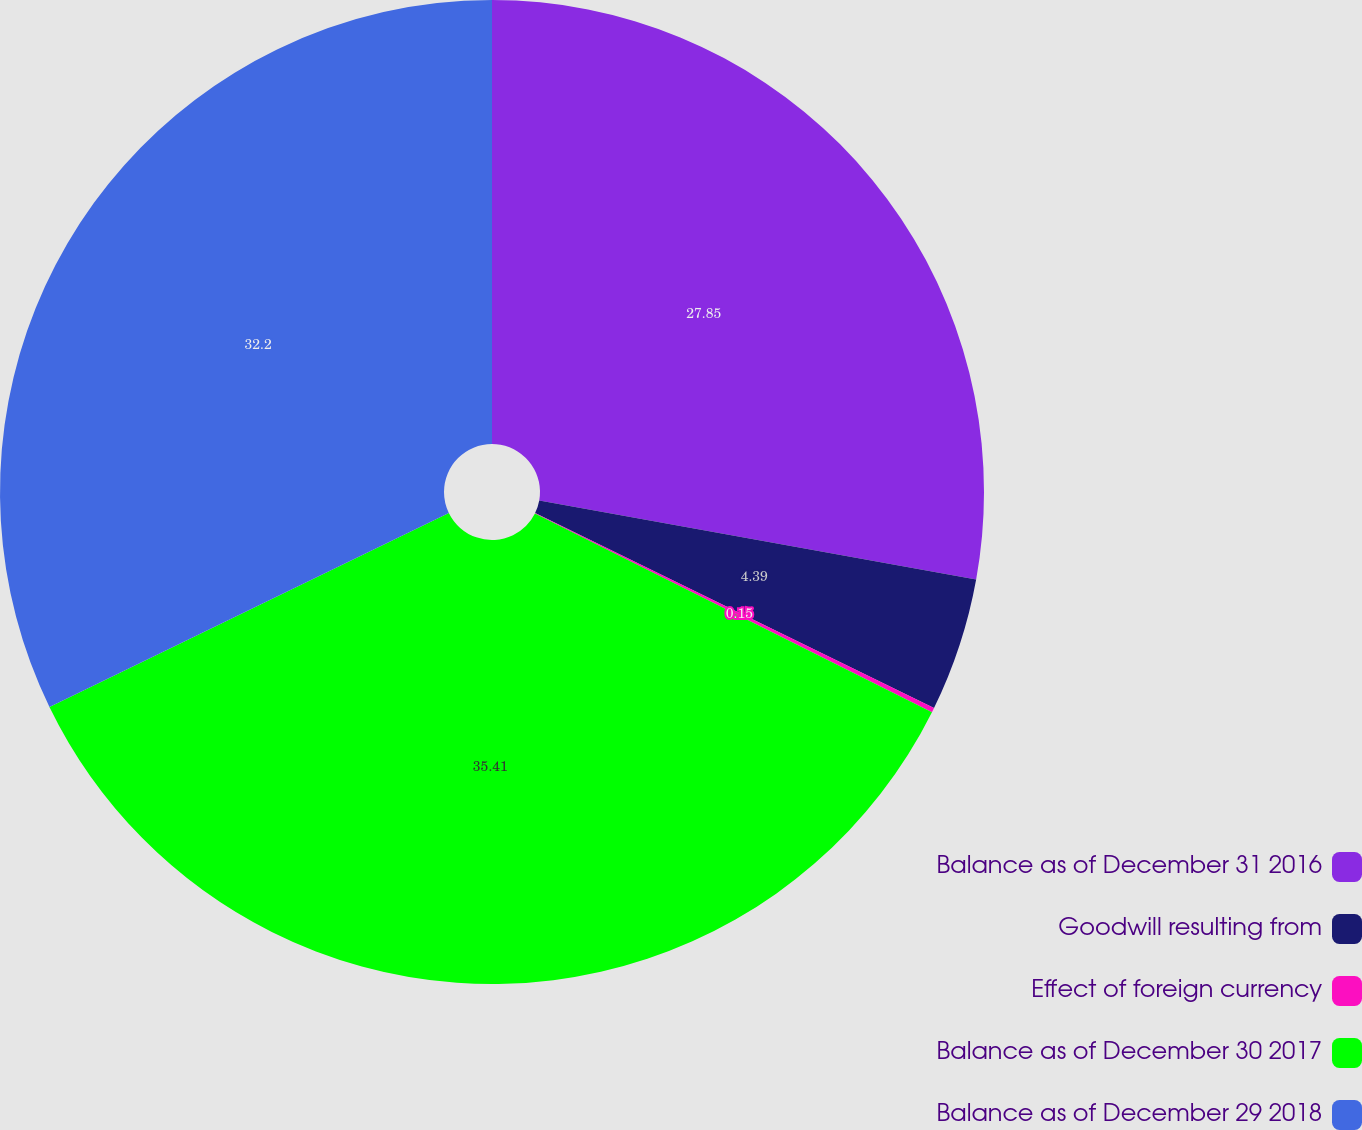Convert chart to OTSL. <chart><loc_0><loc_0><loc_500><loc_500><pie_chart><fcel>Balance as of December 31 2016<fcel>Goodwill resulting from<fcel>Effect of foreign currency<fcel>Balance as of December 30 2017<fcel>Balance as of December 29 2018<nl><fcel>27.85%<fcel>4.39%<fcel>0.15%<fcel>35.42%<fcel>32.2%<nl></chart> 